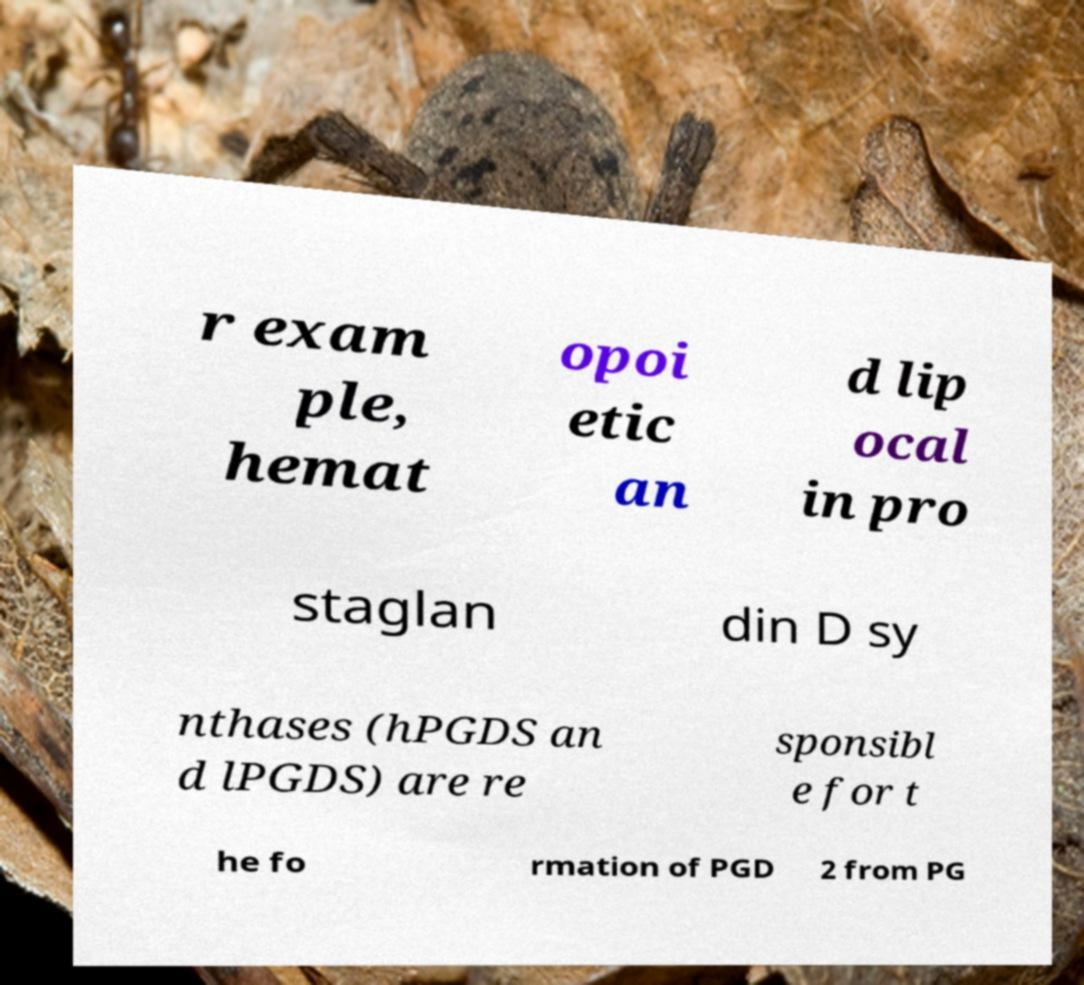There's text embedded in this image that I need extracted. Can you transcribe it verbatim? r exam ple, hemat opoi etic an d lip ocal in pro staglan din D sy nthases (hPGDS an d lPGDS) are re sponsibl e for t he fo rmation of PGD 2 from PG 